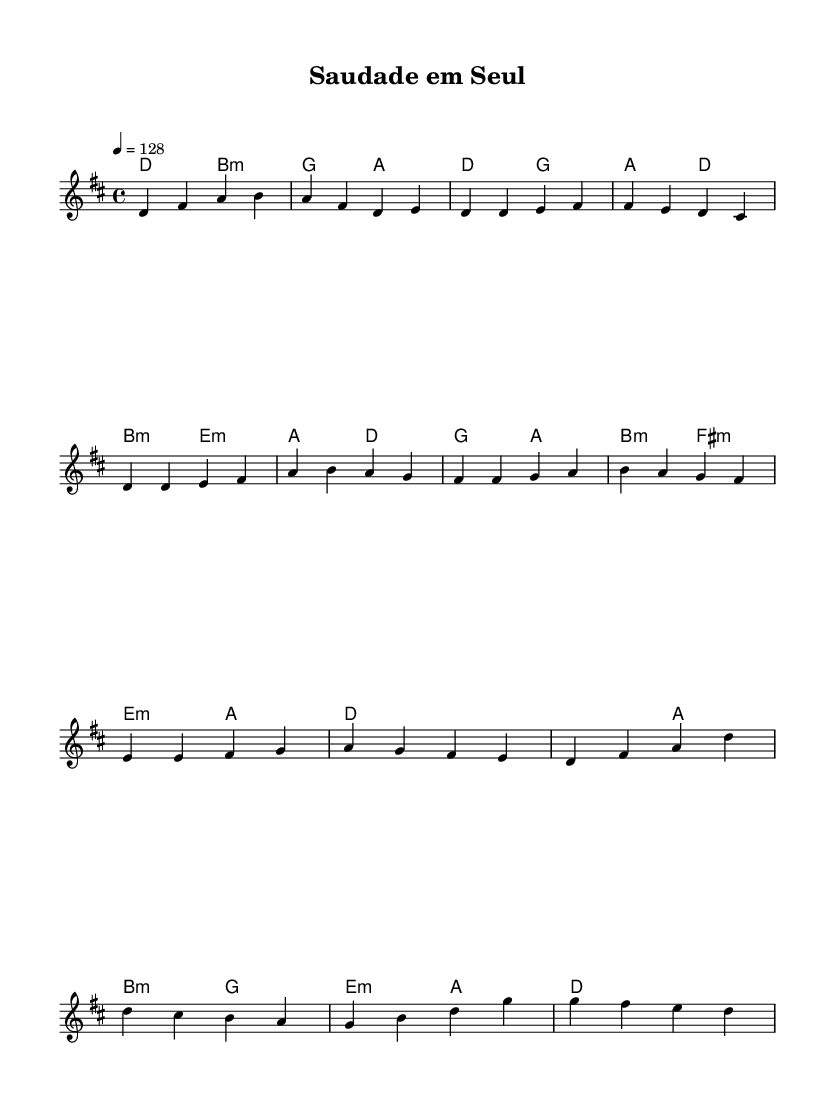What is the key signature of this music? The key signature shown has two sharps, which indicate D major or B minor. The notes played in the piece confirm that it is in D major.
Answer: D major What is the time signature of this piece? The time signature indicated at the beginning is 4/4, which means there are four beats in each measure, and the quarter note gets one beat.
Answer: 4/4 What is the tempo of the piece? The tempo marking in the score is indicated as "4 = 128," which means there are 128 beats per minute. This is a moderate to fast tempo suitable for upbeat tracks.
Answer: 128 How many measures are in the verse section? Counting the measures in the verse section, there are eight measures shown as part of the structure represented in the sheet music.
Answer: 8 What type of chords are used in the pre-chorus section? The pre-chorus section consists of a mix of major and minor chords as shown in the harmonies. Specifically, it uses G major, A major, B minor, and F# minor chords.
Answer: Major and minor Is there a repetition of any section in the music? Yes, the verse section is repeated within the overall structure of the piece, as seen from the layout of the notes in the score.
Answer: Yes What genre does this music primarily represent? The style, tempo, and structure of the piece are characteristic of K-Pop, especially with the upbeat tempo and melodic lines present.
Answer: K-Pop 